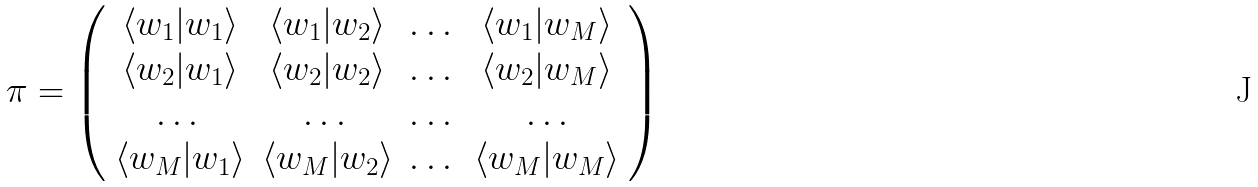<formula> <loc_0><loc_0><loc_500><loc_500>\pi = \left ( \begin{array} { c c c c } \langle w _ { 1 } | w _ { 1 } \rangle & \langle w _ { 1 } | w _ { 2 } \rangle & \dots & \langle w _ { 1 } | w _ { M } \rangle \\ \langle w _ { 2 } | w _ { 1 } \rangle & \langle w _ { 2 } | w _ { 2 } \rangle & \dots & \langle w _ { 2 } | w _ { M } \rangle \\ \dots & \dots & \dots & \dots \\ \langle w _ { M } | w _ { 1 } \rangle & \langle w _ { M } | w _ { 2 } \rangle & \dots & \langle w _ { M } | w _ { M } \rangle \end{array} \right )</formula> 